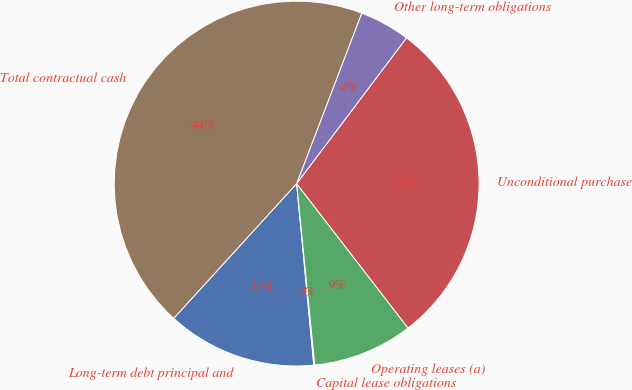Convert chart to OTSL. <chart><loc_0><loc_0><loc_500><loc_500><pie_chart><fcel>Long-term debt principal and<fcel>Capital lease obligations<fcel>Operating leases (a)<fcel>Unconditional purchase<fcel>Other long-term obligations<fcel>Total contractual cash<nl><fcel>13.27%<fcel>0.09%<fcel>8.87%<fcel>29.26%<fcel>4.48%<fcel>44.03%<nl></chart> 